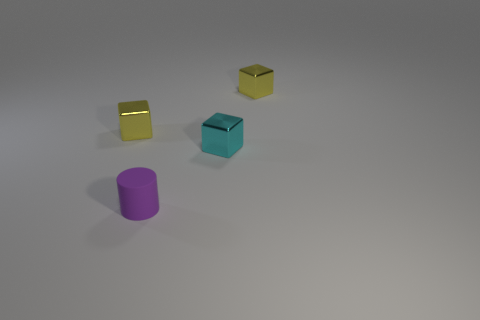There is a shiny cube left of the small cylinder; what color is it? yellow 